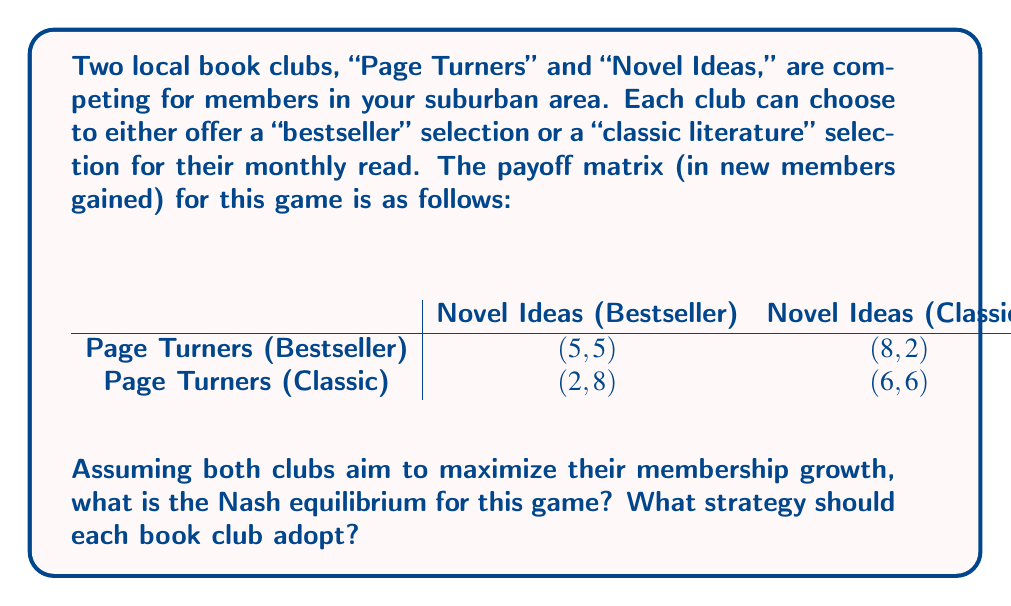Can you solve this math problem? To solve this game theory problem, we need to follow these steps:

1. Identify the dominant strategies (if any) for each player.
2. If there are no dominant strategies, look for Nash equilibria.

Let's analyze the strategies for each book club:

For Page Turners:
- If Novel Ideas chooses Bestseller: Page Turners prefers Bestseller (5 > 2)
- If Novel Ideas chooses Classic: Page Turners prefers Bestseller (8 > 6)

For Novel Ideas:
- If Page Turners chooses Bestseller: Novel Ideas prefers Bestseller (5 > 2)
- If Page Turners chooses Classic: Novel Ideas prefers Bestseller (8 > 6)

We can see that for both clubs, choosing "Bestseller" is a dominant strategy, as it always yields a better payoff regardless of what the other club does.

When both clubs choose their dominant strategy (Bestseller), we arrive at the outcome (5,5). This is a Nash equilibrium because neither club can unilaterally improve their payoff by changing their strategy.

To verify this is the only Nash equilibrium:
- (8,2) is not Nash: Novel Ideas would switch to Bestseller
- (2,8) is not Nash: Page Turners would switch to Bestseller
- (6,6) is not Nash: Both clubs would switch to Bestseller

Therefore, the unique Nash equilibrium for this game is (Bestseller, Bestseller) with a payoff of (5,5).
Answer: The Nash equilibrium for this game is (Bestseller, Bestseller) with a payoff of (5,5). Both "Page Turners" and "Novel Ideas" should adopt the strategy of offering bestseller selections for their monthly reads. 